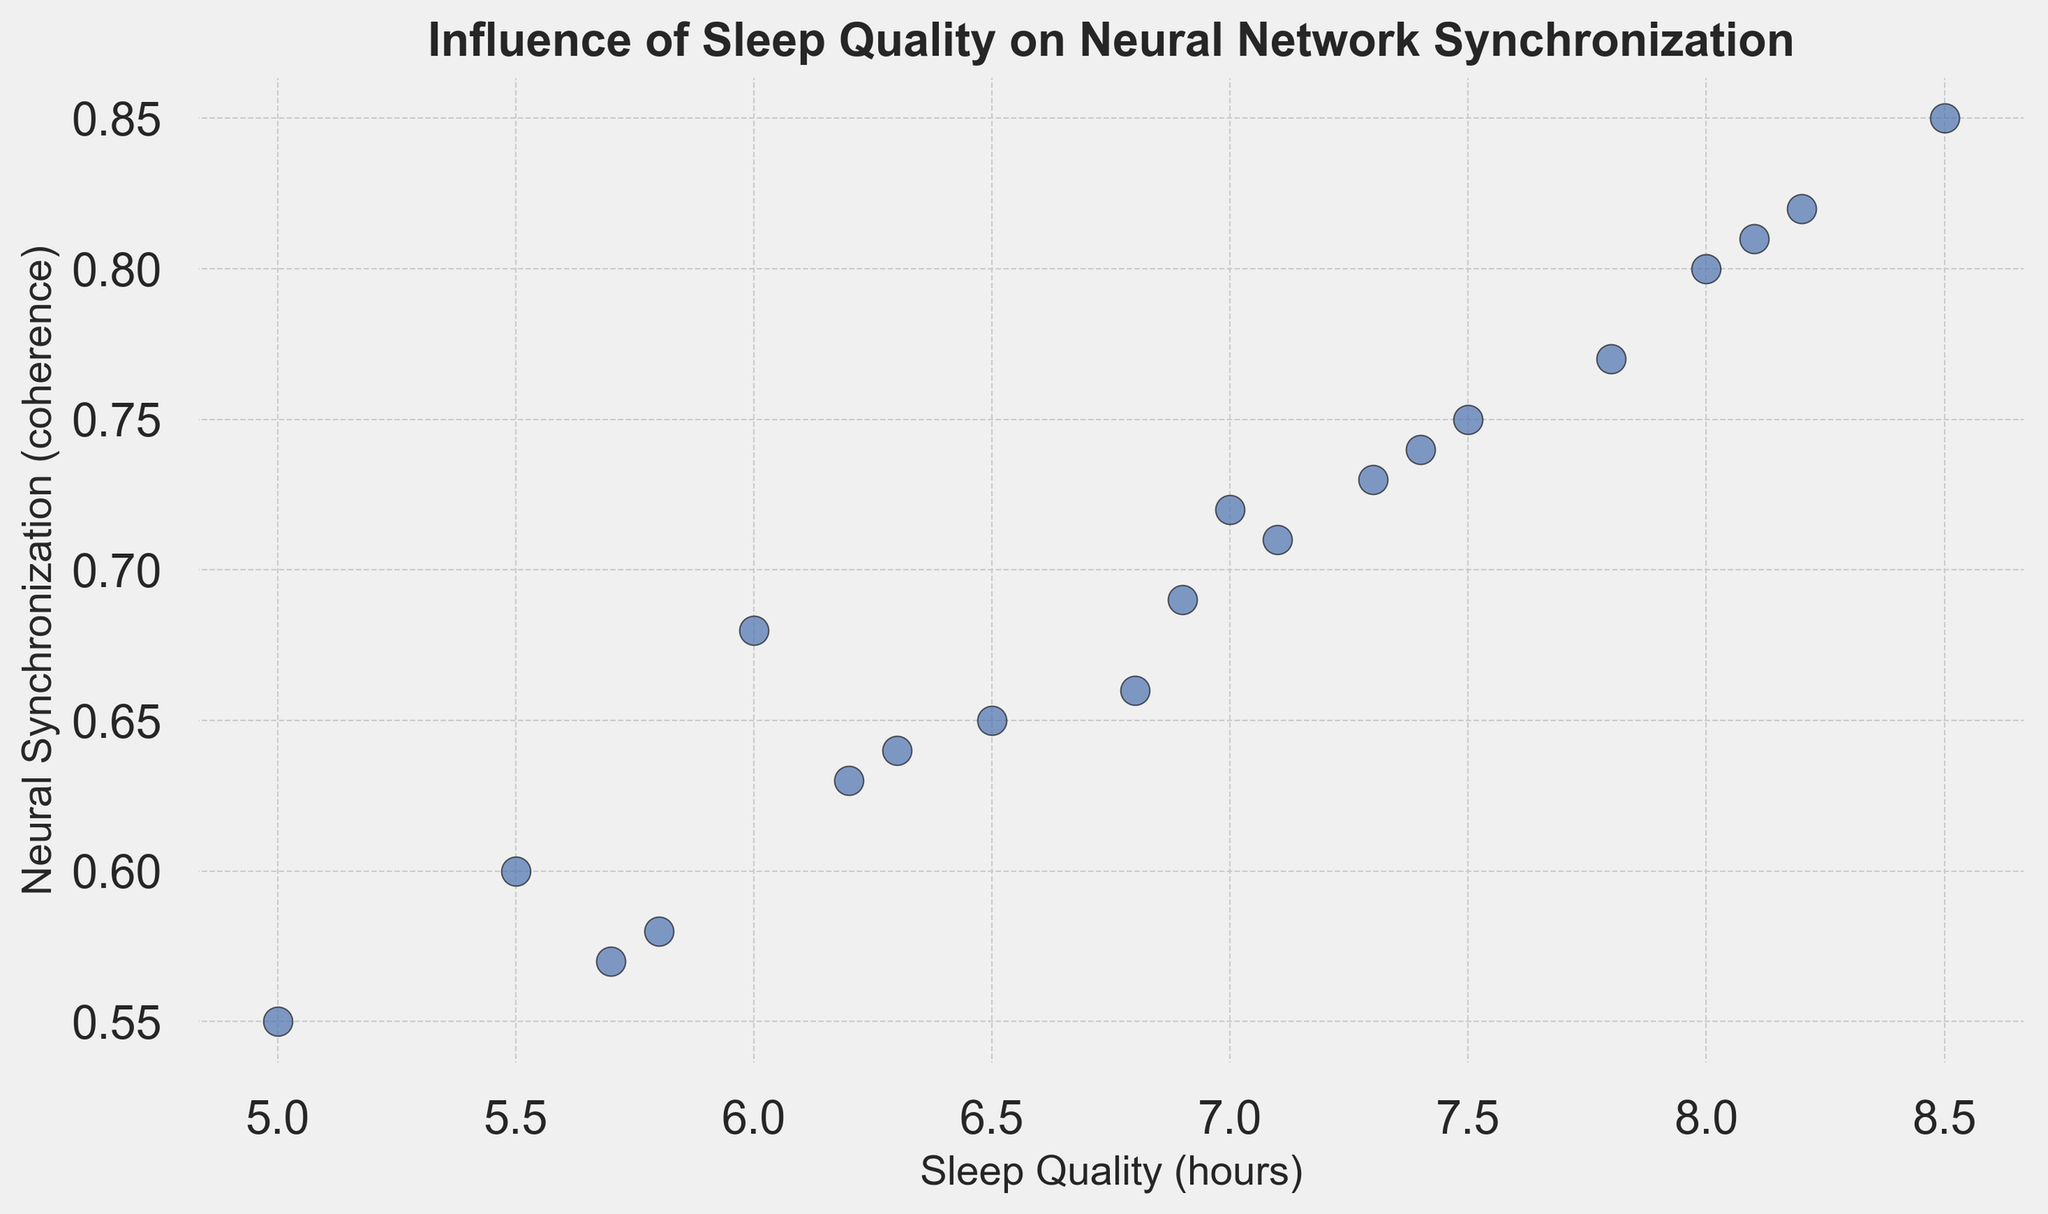What's the range of Sleep Quality values in the plot? Look at the x-axis and identify the minimum and maximum values for Sleep Quality. The lowest value is 5.0 hours, and the highest value is 8.5 hours. Therefore, the range is 8.5 - 5.0.
Answer: 3.5 hours Which data point shows the highest Neural Synchronization? Identify the highest point on the y-axis. The highest value is 0.85, which corresponds to a Sleep Quality of 8.5 hours.
Answer: Sleep Quality of 8.5 hours How many data points have a Sleep Quality of less than 6.0 hours? Count the number of points on the x-axis that are less than 6.0 hours. There are five such points (5.0, 5.5, 5.7, 5.8, 6.0).
Answer: 5 Is there a data point with a Neural Synchronization value of 0.70? Check the y-axis for the value 0.70 and see if there is a corresponding point. The point exists at a Sleep Quality of 7.0 hours.
Answer: Yes What is the average Neural Synchronization value of data points with a Sleep Quality greater than or equal to 7.0 hours? First, identify the data points with a Sleep Quality of 7.0 hours and above. The points are (7.0, 0.72), (7.1, 0.71), (7.3, 0.73), (7.4, 0.74), (7.5, 0.75), (7.8, 0.77), (8.0, 0.80), (8.1, 0.81), (8.2, 0.82), (8.5, 0.85). Then, sum the Neural Synchronization values: 0.72+0.71+0.73+0.74+0.75+0.77+0.80+0.81+0.82+0.85 = 7.90. Finally, divide by the number of points (10).
Answer: 0.79 Compare the Neural Synchronization values of the points with a Sleep Quality of 6.0 and 7.5 hours. Which is higher? Look at the y-axis values for Sleep Quality of 6.0 hours and 7.5 hours. The values are 0.68 and 0.75 respectively. 0.75 is higher than 0.68.
Answer: 7.5 hours Is there a positive correlation between Sleep Quality and Neural Synchronization? Look at the scatter plot's general trend. Higher Sleep Quality values are associated with higher Neural Synchronization values, indicating a positive correlation.
Answer: Yes What's the median value of Neural Synchronization? List all Neural Synchronization values in ascending order: 0.55, 0.57, 0.58, 0.60, 0.63, 0.64, 0.65, 0.66, 0.68, 0.69, 0.71, 0.72, 0.73, 0.74, 0.75, 0.77, 0.80, 0.81, 0.82, 0.85. The middle value in this list is the median, which corresponds to the 10th and 11th values in a list of 20 points: (0.69 + 0.71) / 2.
Answer: 0.70 What's the difference between the highest and lowest Neural Synchronization values? Identify the highest and lowest Neural Synchronization values. The highest is 0.85, and the lowest is 0.55. The difference is 0.85 - 0.55.
Answer: 0.30 